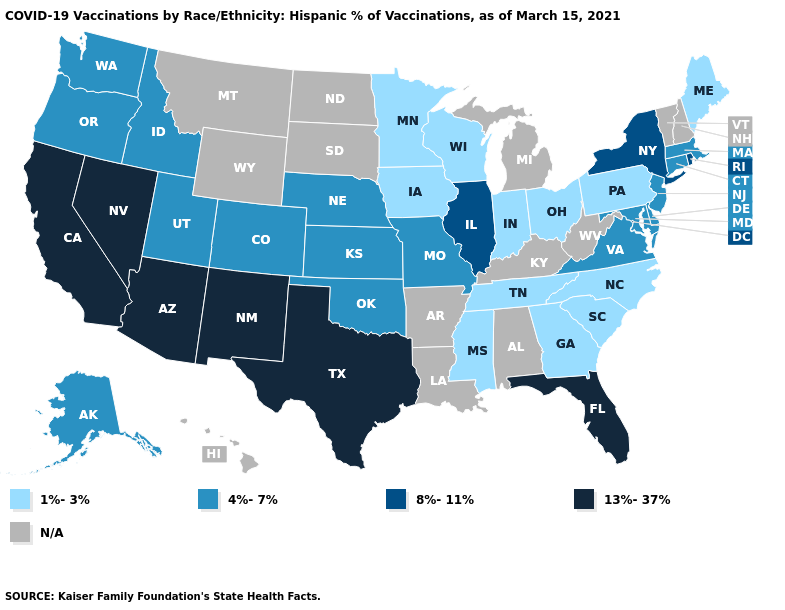What is the value of California?
Answer briefly. 13%-37%. Name the states that have a value in the range 8%-11%?
Give a very brief answer. Illinois, New York, Rhode Island. Name the states that have a value in the range 13%-37%?
Keep it brief. Arizona, California, Florida, Nevada, New Mexico, Texas. Which states have the lowest value in the MidWest?
Give a very brief answer. Indiana, Iowa, Minnesota, Ohio, Wisconsin. What is the value of Utah?
Write a very short answer. 4%-7%. What is the value of Vermont?
Answer briefly. N/A. What is the lowest value in the Northeast?
Answer briefly. 1%-3%. What is the value of Wisconsin?
Be succinct. 1%-3%. Does South Carolina have the highest value in the USA?
Short answer required. No. What is the lowest value in the USA?
Give a very brief answer. 1%-3%. Does the first symbol in the legend represent the smallest category?
Write a very short answer. Yes. Name the states that have a value in the range 4%-7%?
Keep it brief. Alaska, Colorado, Connecticut, Delaware, Idaho, Kansas, Maryland, Massachusetts, Missouri, Nebraska, New Jersey, Oklahoma, Oregon, Utah, Virginia, Washington. What is the highest value in states that border Massachusetts?
Keep it brief. 8%-11%. 